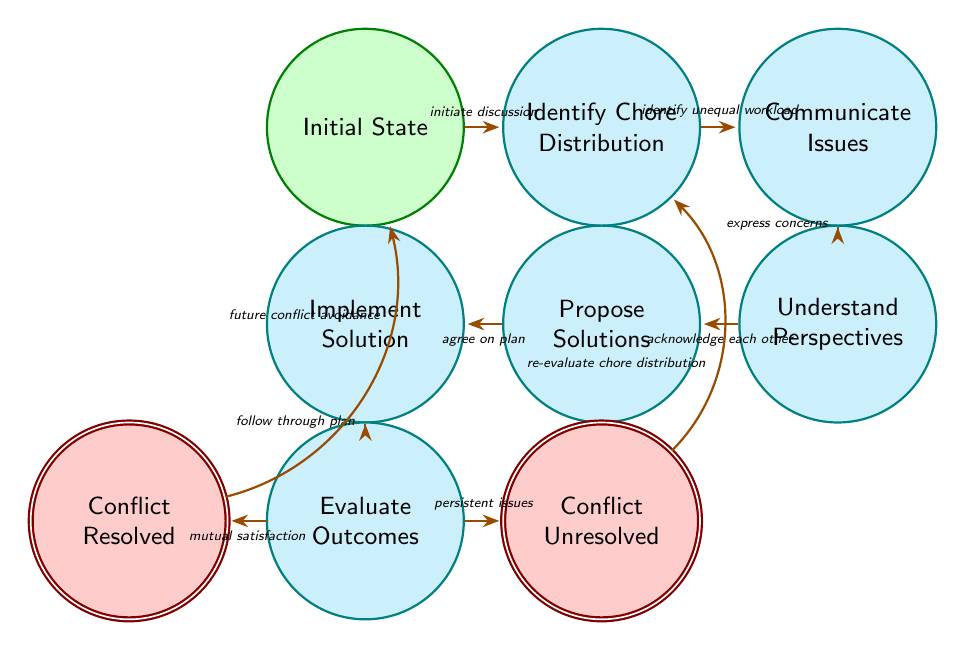What is the initial state in this diagram? The initial state starts the process of resolving household chores conflict and is labeled as "Initial State" in the diagram.
Answer: Initial State How many states are there in the diagram? By counting the unique nodes labeled in the diagram, we find that there are a total of nine distinct states listed.
Answer: Nine What triggers the transition from "Communicate Issues" to "Understand Perspectives"? The transition from "Communicate Issues" to "Understand Perspectives" occurs when the participants in the conflict "express concerns," which is indicated as the trigger for that edge in the diagram.
Answer: express concerns Which state leads to "Conflict Resolved"? The state that leads to "Conflict Resolved" is "Evaluate Outcomes," which transitions to "Conflict Resolved" upon achieving "mutual satisfaction."
Answer: Evaluate Outcomes What is the transition that can cause the return to "Identify Chore Distribution"? The transition that can lead back to "Identify Chore Distribution" occurs when both parties have "persistent issues," which is indicated as a trigger in the diagram.
Answer: persistent issues What happens after "Conflict Unresolved"? After reaching "Conflict Unresolved," the next step involves re-evaluating the chore distribution, as indicated by the transition that leads back to the "Identify Chore Distribution" state.
Answer: re-evaluate chore distribution What is the relationship between "Implement Solution" and "Evaluate Outcomes"? "Implement Solution" directly transitions to "Evaluate Outcomes" when the plan is followed through, indicating a progression in the chore-resolution process.
Answer: Follow through plan How does one avoid future conflicts after resolving the current one? To avoid future conflicts after resolving the current one, the process suggests returning to the "Initial State" through the transition labeled as "future conflict avoidance."
Answer: future conflict avoidance 